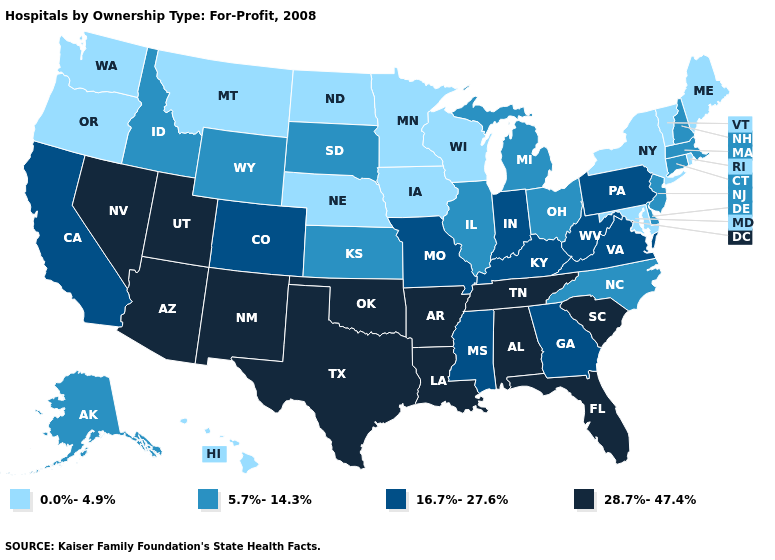Name the states that have a value in the range 28.7%-47.4%?
Short answer required. Alabama, Arizona, Arkansas, Florida, Louisiana, Nevada, New Mexico, Oklahoma, South Carolina, Tennessee, Texas, Utah. Name the states that have a value in the range 28.7%-47.4%?
Quick response, please. Alabama, Arizona, Arkansas, Florida, Louisiana, Nevada, New Mexico, Oklahoma, South Carolina, Tennessee, Texas, Utah. What is the lowest value in the USA?
Give a very brief answer. 0.0%-4.9%. Does Colorado have the highest value in the West?
Concise answer only. No. Which states have the highest value in the USA?
Give a very brief answer. Alabama, Arizona, Arkansas, Florida, Louisiana, Nevada, New Mexico, Oklahoma, South Carolina, Tennessee, Texas, Utah. What is the value of Missouri?
Answer briefly. 16.7%-27.6%. Among the states that border Wisconsin , does Michigan have the lowest value?
Give a very brief answer. No. Name the states that have a value in the range 5.7%-14.3%?
Be succinct. Alaska, Connecticut, Delaware, Idaho, Illinois, Kansas, Massachusetts, Michigan, New Hampshire, New Jersey, North Carolina, Ohio, South Dakota, Wyoming. Does the first symbol in the legend represent the smallest category?
Be succinct. Yes. Name the states that have a value in the range 0.0%-4.9%?
Concise answer only. Hawaii, Iowa, Maine, Maryland, Minnesota, Montana, Nebraska, New York, North Dakota, Oregon, Rhode Island, Vermont, Washington, Wisconsin. What is the value of Maryland?
Be succinct. 0.0%-4.9%. Does Maryland have the lowest value in the South?
Short answer required. Yes. What is the highest value in the South ?
Give a very brief answer. 28.7%-47.4%. Is the legend a continuous bar?
Be succinct. No. What is the lowest value in the USA?
Concise answer only. 0.0%-4.9%. 